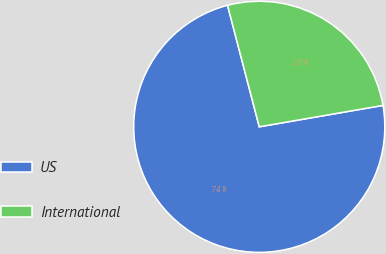Convert chart. <chart><loc_0><loc_0><loc_500><loc_500><pie_chart><fcel>US<fcel>International<nl><fcel>73.66%<fcel>26.34%<nl></chart> 